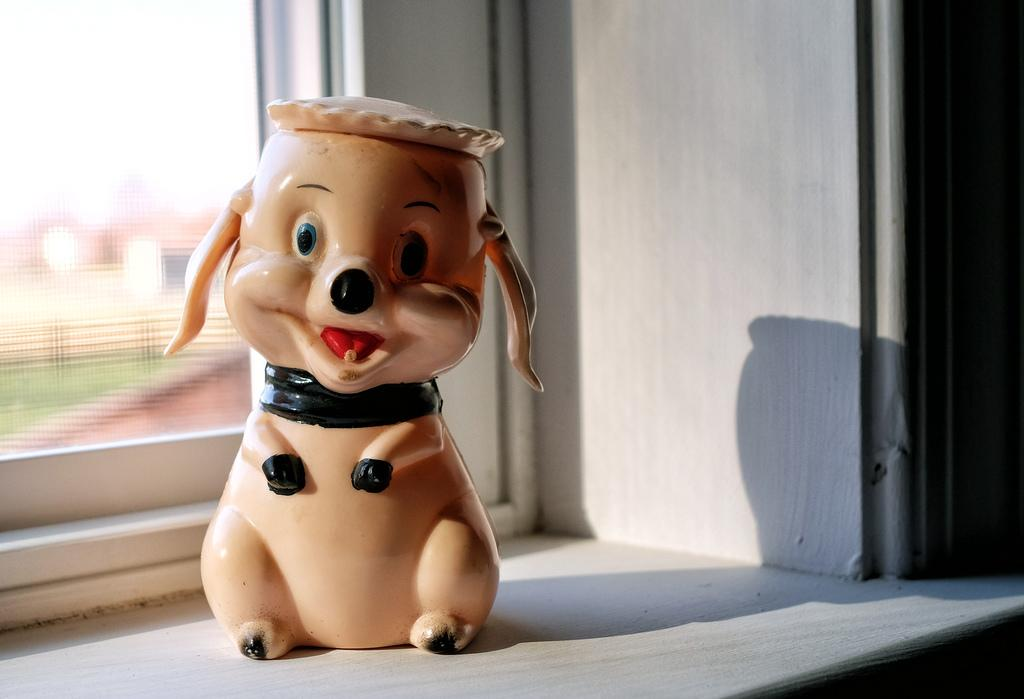What is the main subject in the center of the image? There is a doll in the center of the image. What color is the surface on which the doll is placed? The doll is on a white color surface. What can be seen in the background of the image? There is a window in the background of the image. Can you see a stream flowing through the window in the image? There is no stream visible in the image; only a window can be seen in the background. 